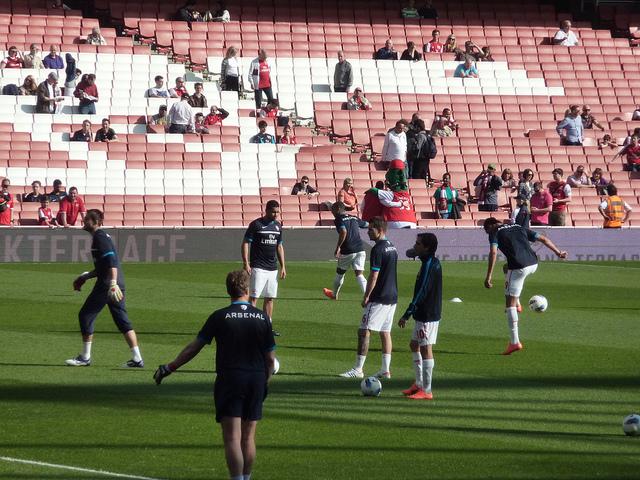How many players are on the field?
Quick response, please. 7. What color is the man's shirt who is running on the sideline?
Give a very brief answer. Black. What sport is this?
Quick response, please. Soccer. Is this a soccer game?
Quick response, please. Yes. The team players are wearing what color running shoes?
Answer briefly. Red. Is this a professional game?
Answer briefly. Yes. 